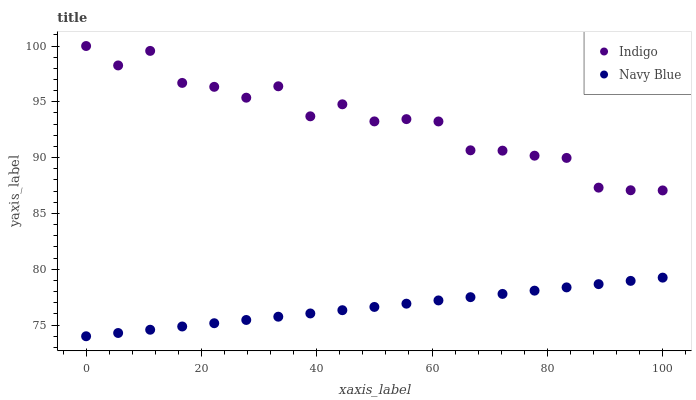Does Navy Blue have the minimum area under the curve?
Answer yes or no. Yes. Does Indigo have the maximum area under the curve?
Answer yes or no. Yes. Does Indigo have the minimum area under the curve?
Answer yes or no. No. Is Navy Blue the smoothest?
Answer yes or no. Yes. Is Indigo the roughest?
Answer yes or no. Yes. Is Indigo the smoothest?
Answer yes or no. No. Does Navy Blue have the lowest value?
Answer yes or no. Yes. Does Indigo have the lowest value?
Answer yes or no. No. Does Indigo have the highest value?
Answer yes or no. Yes. Is Navy Blue less than Indigo?
Answer yes or no. Yes. Is Indigo greater than Navy Blue?
Answer yes or no. Yes. Does Navy Blue intersect Indigo?
Answer yes or no. No. 